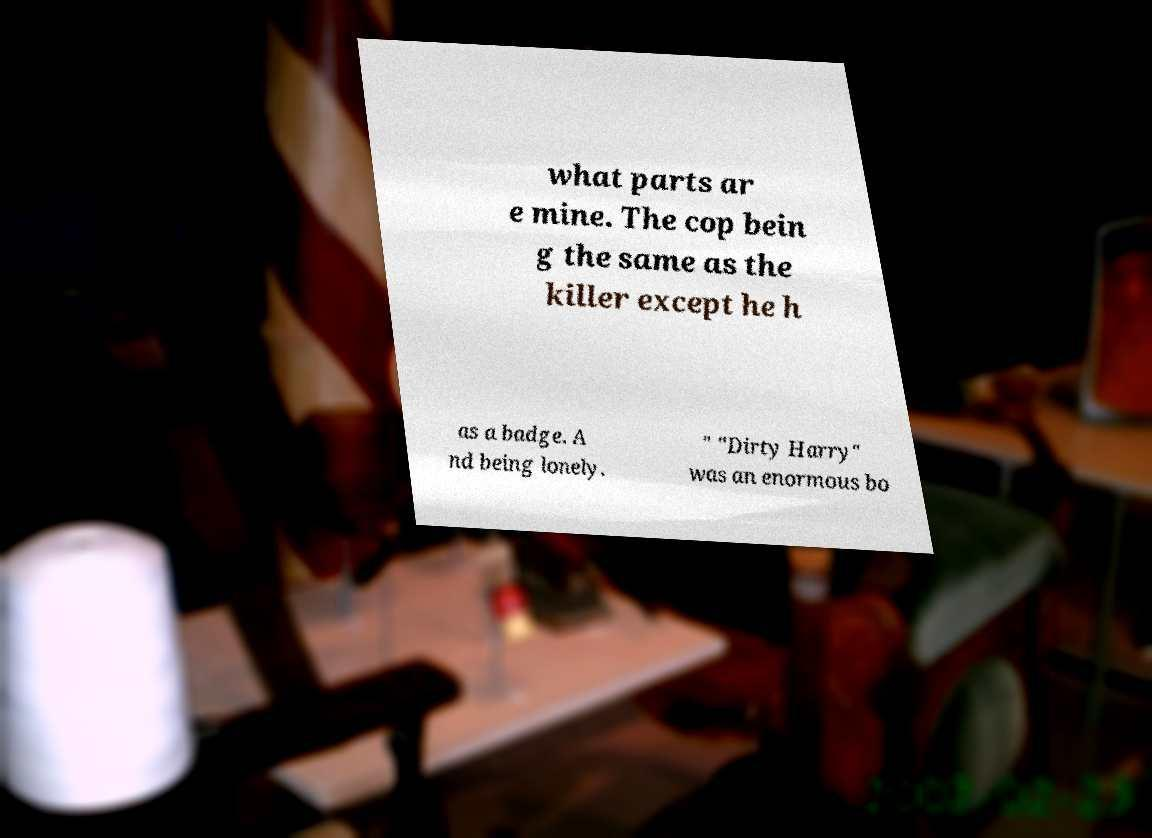For documentation purposes, I need the text within this image transcribed. Could you provide that? what parts ar e mine. The cop bein g the same as the killer except he h as a badge. A nd being lonely. " "Dirty Harry" was an enormous bo 